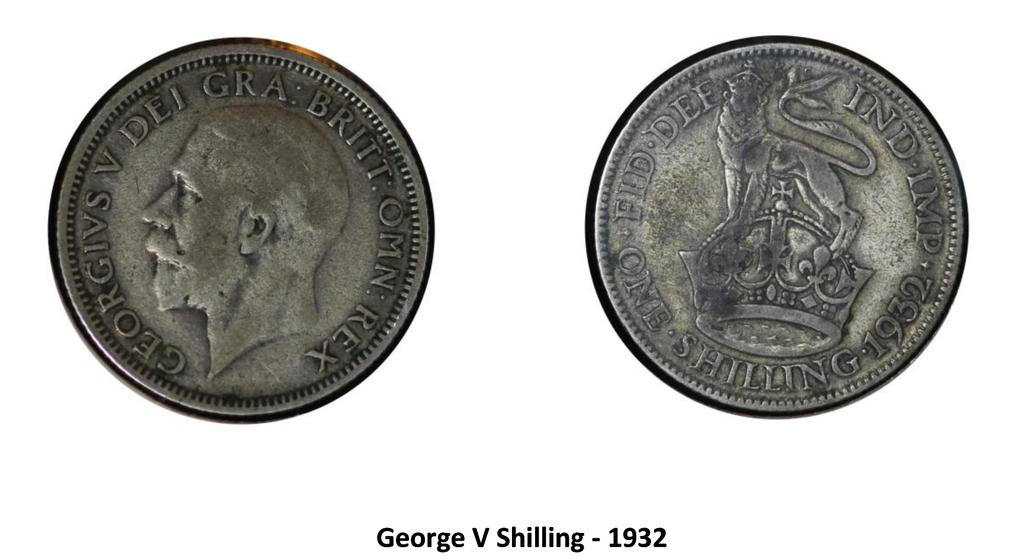<image>
Give a short and clear explanation of the subsequent image. A pair of coins sit alongside one another, one of them with shilling written on it. 